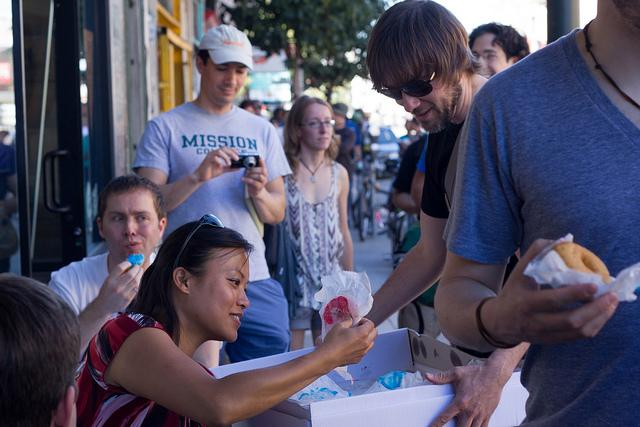What is the man wearing a hat doing with the camera? Please explain your reasoning. taking pictures. The man is taking photos. 